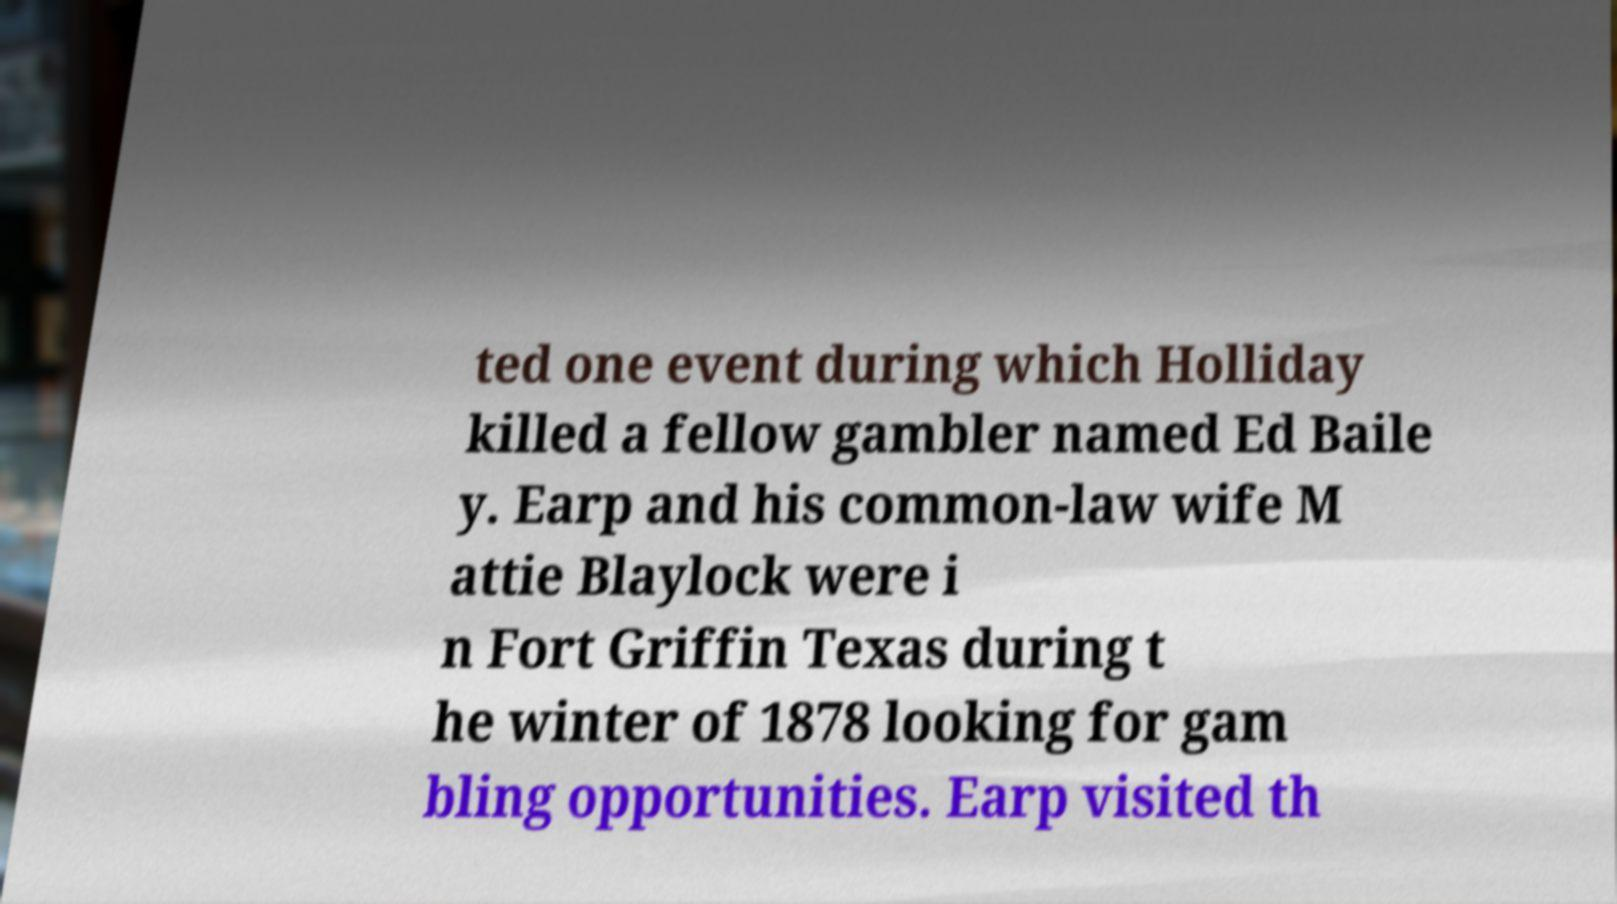Can you accurately transcribe the text from the provided image for me? ted one event during which Holliday killed a fellow gambler named Ed Baile y. Earp and his common-law wife M attie Blaylock were i n Fort Griffin Texas during t he winter of 1878 looking for gam bling opportunities. Earp visited th 